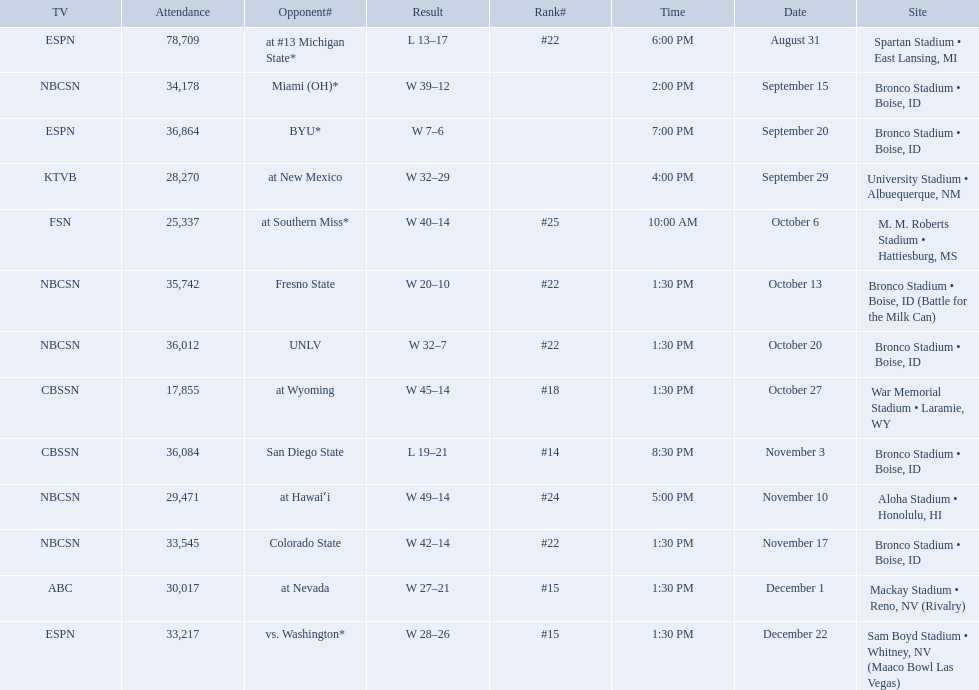Who were all of the opponents? At #13 michigan state*, miami (oh)*, byu*, at new mexico, at southern miss*, fresno state, unlv, at wyoming, san diego state, at hawaiʻi, colorado state, at nevada, vs. washington*. Who did they face on november 3rd? San Diego State. What rank were they on november 3rd? #14. 